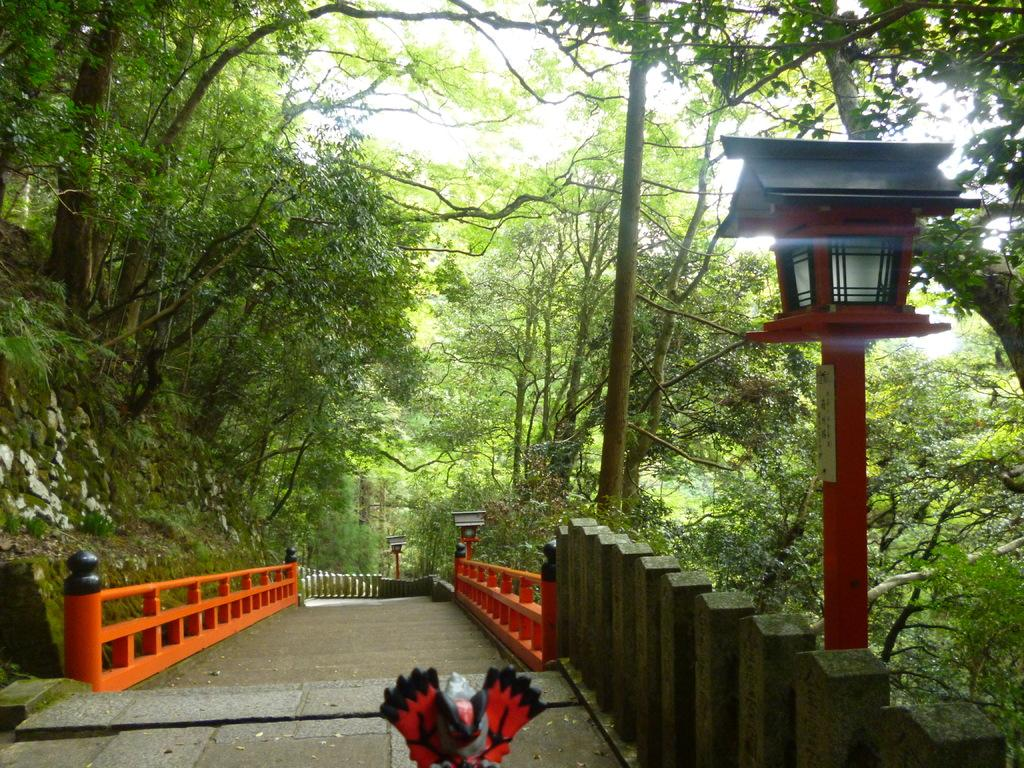What color is the railing in the image? The railing in the image is orange. What can be seen on the right side of the image? There is a red color pole on the right side of the image. What type of vegetation is visible in the background of the image? There are green color trees in the background of the image. What is visible in the background of the image besides the trees? The sky is visible in the background of the image. What is the temperature of the sand in the image? There is no sand present in the image, so it is not possible to determine the temperature. What type of rod is being used to measure the degree in the image? There is no rod or degree measurement present in the image. 